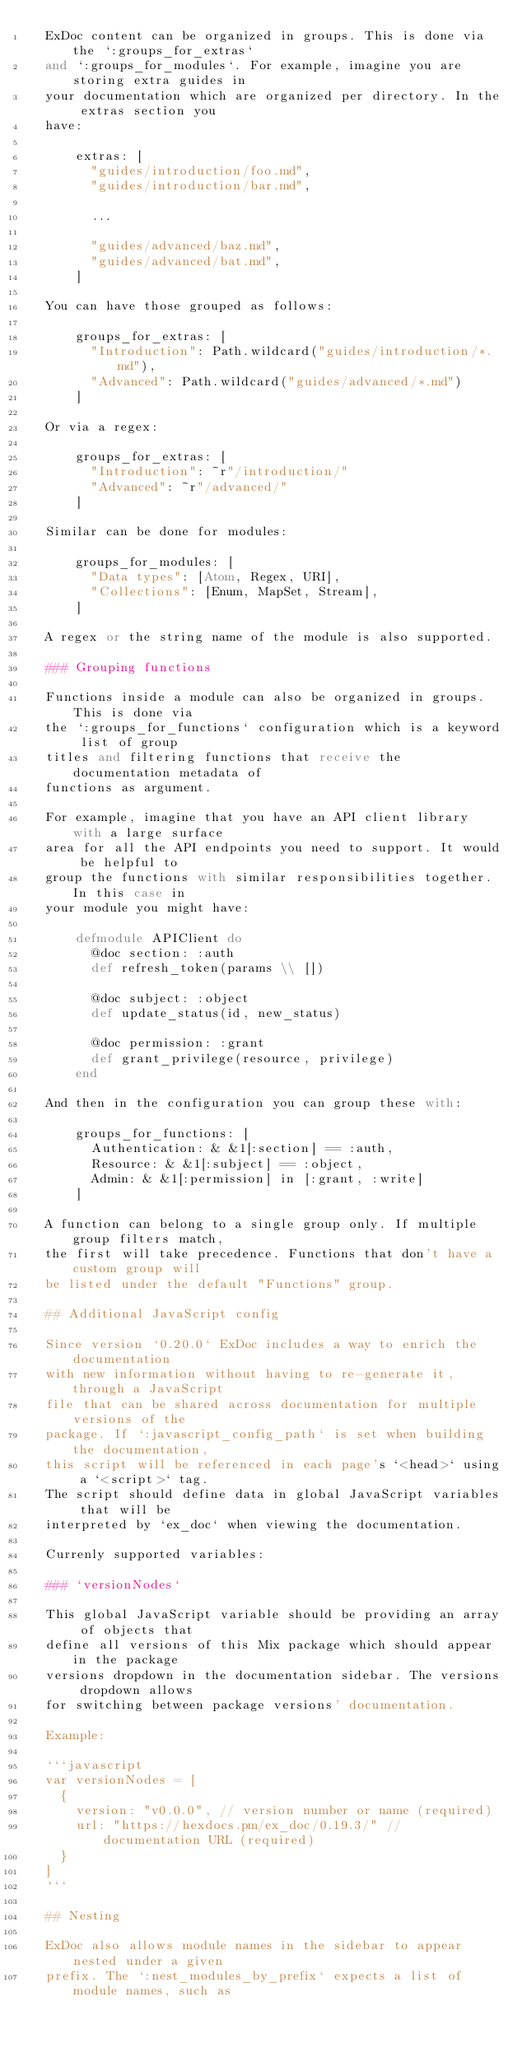<code> <loc_0><loc_0><loc_500><loc_500><_Elixir_>  ExDoc content can be organized in groups. This is done via the `:groups_for_extras`
  and `:groups_for_modules`. For example, imagine you are storing extra guides in
  your documentation which are organized per directory. In the extras section you
  have:

      extras: [
        "guides/introduction/foo.md",
        "guides/introduction/bar.md",

        ...

        "guides/advanced/baz.md",
        "guides/advanced/bat.md",
      ]

  You can have those grouped as follows:

      groups_for_extras: [
        "Introduction": Path.wildcard("guides/introduction/*.md"),
        "Advanced": Path.wildcard("guides/advanced/*.md")
      ]

  Or via a regex:

      groups_for_extras: [
        "Introduction": ~r"/introduction/"
        "Advanced": ~r"/advanced/"
      ]

  Similar can be done for modules:

      groups_for_modules: [
        "Data types": [Atom, Regex, URI],
        "Collections": [Enum, MapSet, Stream],
      ]

  A regex or the string name of the module is also supported.

  ### Grouping functions

  Functions inside a module can also be organized in groups. This is done via
  the `:groups_for_functions` configuration which is a keyword list of group
  titles and filtering functions that receive the documentation metadata of
  functions as argument.

  For example, imagine that you have an API client library with a large surface
  area for all the API endpoints you need to support. It would be helpful to
  group the functions with similar responsibilities together. In this case in
  your module you might have:

      defmodule APIClient do
        @doc section: :auth
        def refresh_token(params \\ [])

        @doc subject: :object
        def update_status(id, new_status)

        @doc permission: :grant
        def grant_privilege(resource, privilege)
      end

  And then in the configuration you can group these with:

      groups_for_functions: [
        Authentication: & &1[:section] == :auth,
        Resource: & &1[:subject] == :object,
        Admin: & &1[:permission] in [:grant, :write]
      ]

  A function can belong to a single group only. If multiple group filters match,
  the first will take precedence. Functions that don't have a custom group will
  be listed under the default "Functions" group.

  ## Additional JavaScript config

  Since version `0.20.0` ExDoc includes a way to enrich the documentation
  with new information without having to re-generate it, through a JavaScript
  file that can be shared across documentation for multiple versions of the
  package. If `:javascript_config_path` is set when building the documentation,
  this script will be referenced in each page's `<head>` using a `<script>` tag.
  The script should define data in global JavaScript variables that will be
  interpreted by `ex_doc` when viewing the documentation.

  Currenly supported variables:

  ### `versionNodes`

  This global JavaScript variable should be providing an array of objects that
  define all versions of this Mix package which should appear in the package
  versions dropdown in the documentation sidebar. The versions dropdown allows
  for switching between package versions' documentation.

  Example:

  ```javascript
  var versionNodes = [
    {
      version: "v0.0.0", // version number or name (required)
      url: "https://hexdocs.pm/ex_doc/0.19.3/" // documentation URL (required)
    }
  ]
  ```

  ## Nesting

  ExDoc also allows module names in the sidebar to appear nested under a given
  prefix. The `:nest_modules_by_prefix` expects a list of module names, such as</code> 